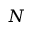<formula> <loc_0><loc_0><loc_500><loc_500>N</formula> 